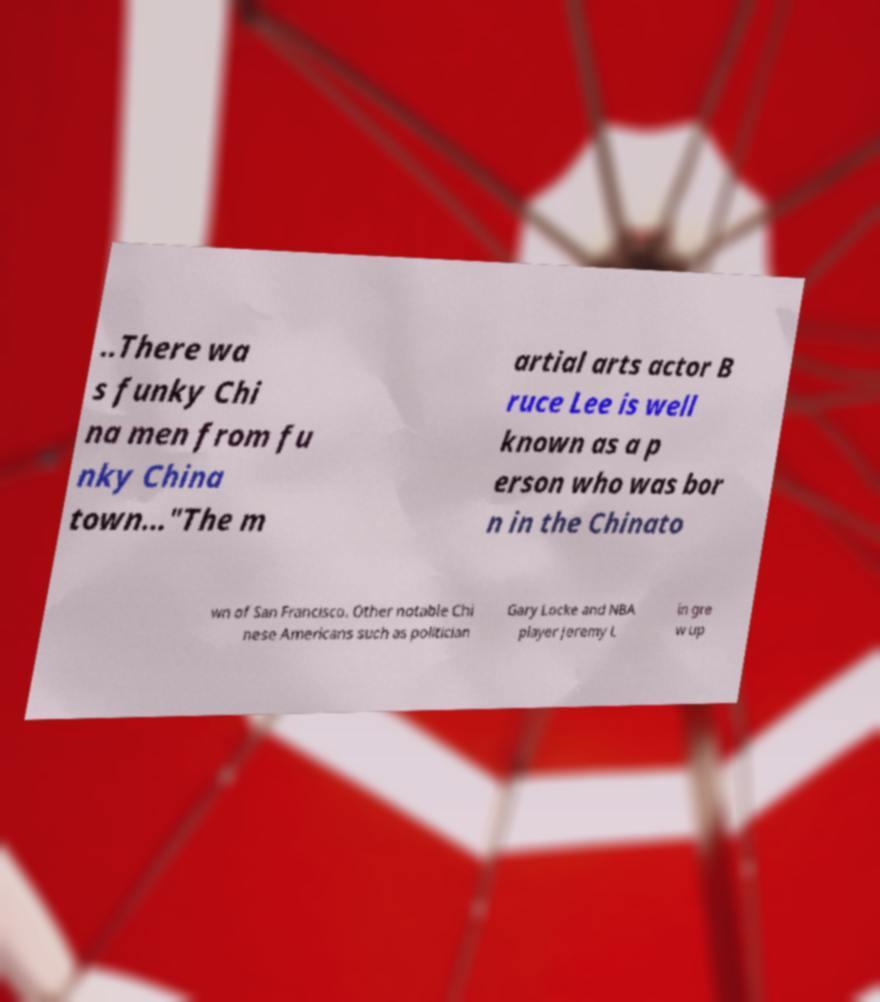What messages or text are displayed in this image? I need them in a readable, typed format. ..There wa s funky Chi na men from fu nky China town..."The m artial arts actor B ruce Lee is well known as a p erson who was bor n in the Chinato wn of San Francisco. Other notable Chi nese Americans such as politician Gary Locke and NBA player Jeremy L in gre w up 